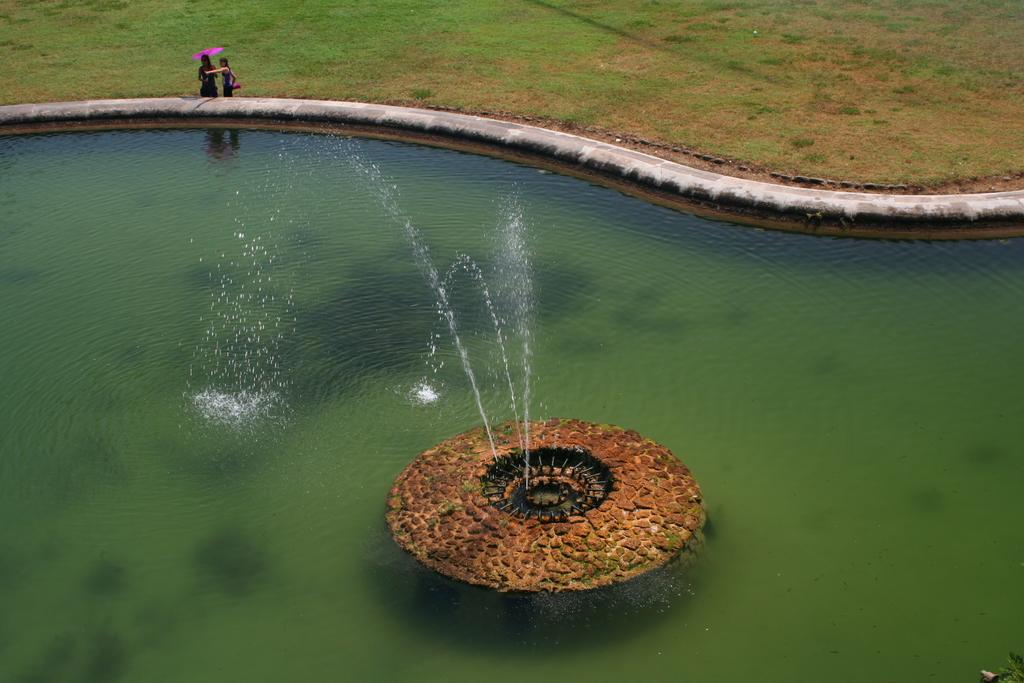What is in the swimming pool in the image? There is a fountain in the swimming pool. Can you describe the people in the background? There are two people in the background, and one of them is holding an umbrella. What type of surface can be seen in the image? There is ground visible in the image. What type of mind can be seen in the image? There is no mind present in the image; it features a fountain in a swimming pool and people in the background. What is the purpose of the calculator in the image? There is no calculator present in the image. 